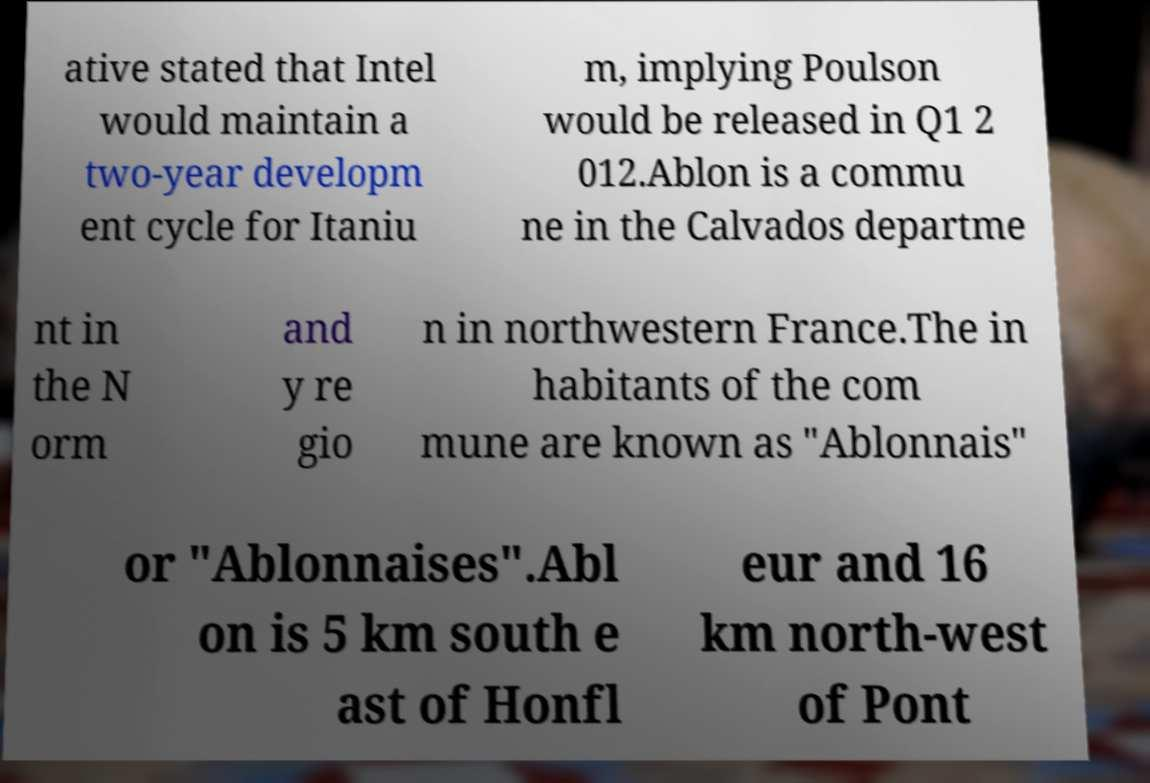What messages or text are displayed in this image? I need them in a readable, typed format. ative stated that Intel would maintain a two-year developm ent cycle for Itaniu m, implying Poulson would be released in Q1 2 012.Ablon is a commu ne in the Calvados departme nt in the N orm and y re gio n in northwestern France.The in habitants of the com mune are known as "Ablonnais" or "Ablonnaises".Abl on is 5 km south e ast of Honfl eur and 16 km north-west of Pont 